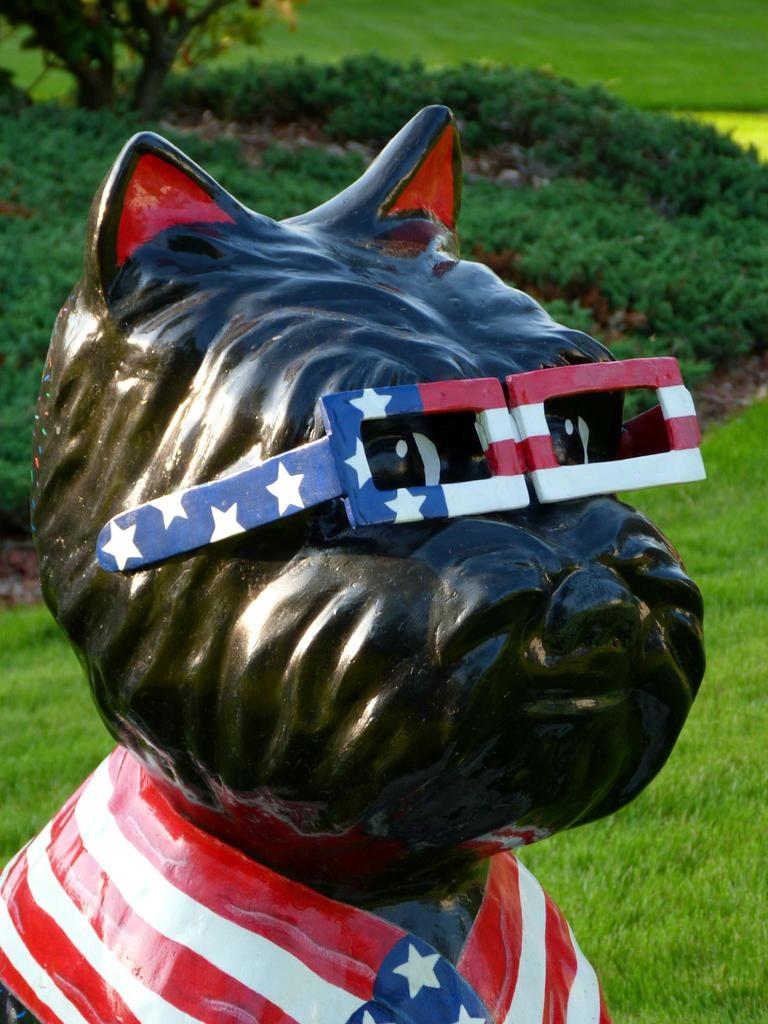What is the main subject of the image? There is a sculpture of an animal in the image. What is unique about the animal sculpture? The animal sculpture is wearing spectacles. What can be seen in the background of the image? There is grass, plants, and trees visible in the background of the image. How does the animal sculpture stop the fire from burning the plants in the image? There is no fire or burning plants present in the image, and the animal sculpture does not have any apparent means to stop a fire. 